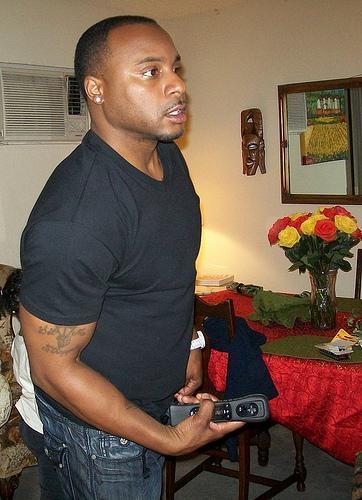How many people are in the scene?
Give a very brief answer. 1. 